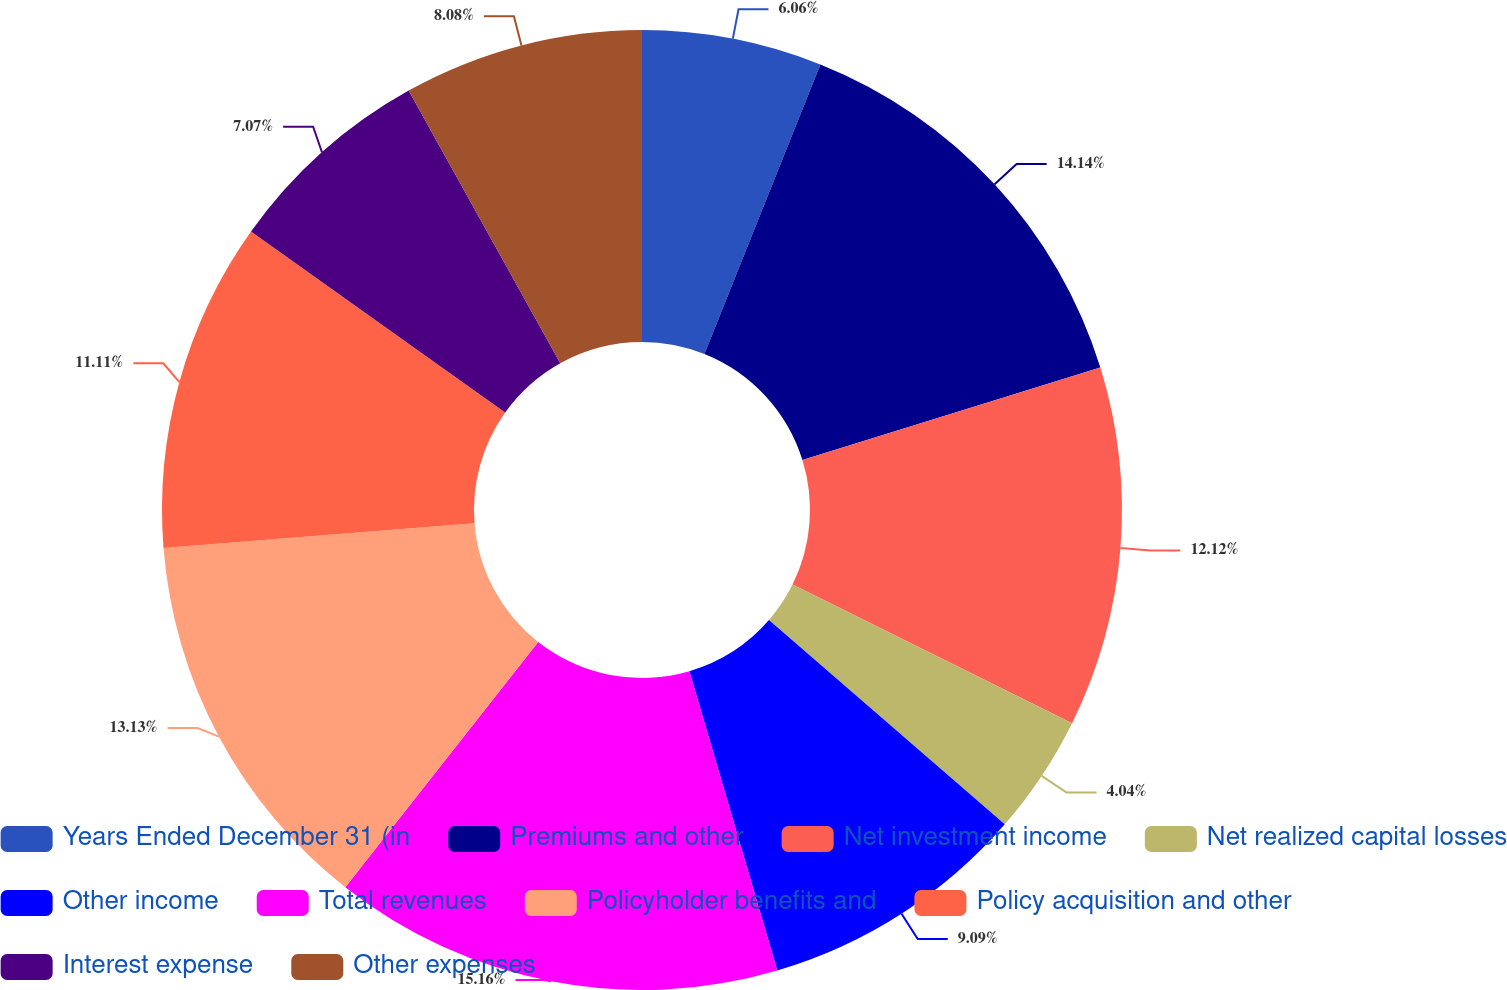<chart> <loc_0><loc_0><loc_500><loc_500><pie_chart><fcel>Years Ended December 31 (in<fcel>Premiums and other<fcel>Net investment income<fcel>Net realized capital losses<fcel>Other income<fcel>Total revenues<fcel>Policyholder benefits and<fcel>Policy acquisition and other<fcel>Interest expense<fcel>Other expenses<nl><fcel>6.06%<fcel>14.14%<fcel>12.12%<fcel>4.04%<fcel>9.09%<fcel>15.15%<fcel>13.13%<fcel>11.11%<fcel>7.07%<fcel>8.08%<nl></chart> 